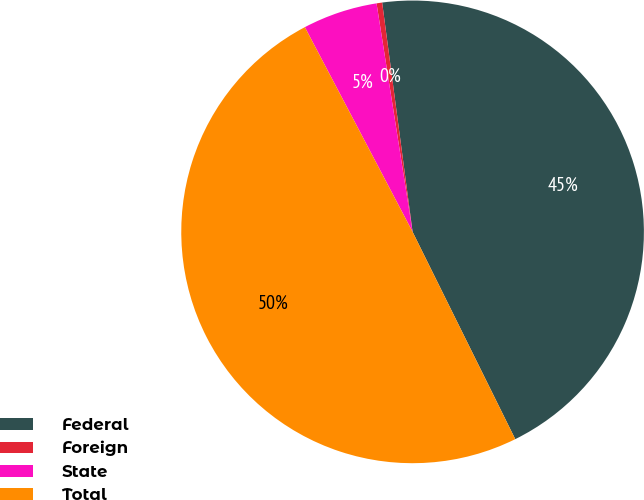<chart> <loc_0><loc_0><loc_500><loc_500><pie_chart><fcel>Federal<fcel>Foreign<fcel>State<fcel>Total<nl><fcel>44.78%<fcel>0.39%<fcel>5.22%<fcel>49.61%<nl></chart> 